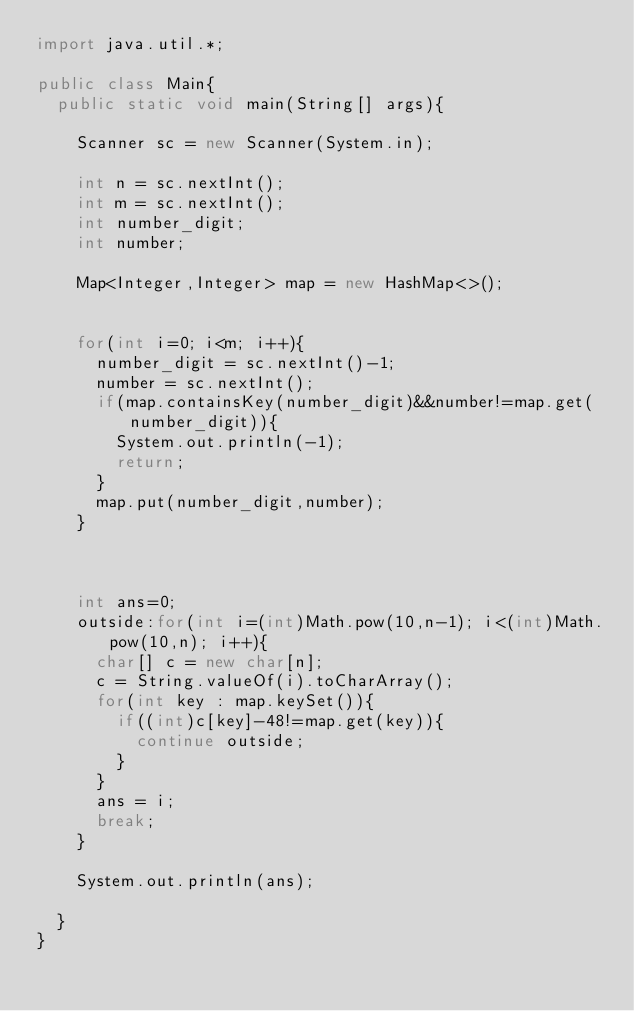<code> <loc_0><loc_0><loc_500><loc_500><_Java_>import java.util.*;

public class Main{
  public static void main(String[] args){

    Scanner sc = new Scanner(System.in);

    int n = sc.nextInt();
    int m = sc.nextInt();
    int number_digit;
    int number;

    Map<Integer,Integer> map = new HashMap<>();


    for(int i=0; i<m; i++){
      number_digit = sc.nextInt()-1;
      number = sc.nextInt();
      if(map.containsKey(number_digit)&&number!=map.get(number_digit)){
        System.out.println(-1);
        return;
      }
      map.put(number_digit,number);
    }



    int ans=0;
    outside:for(int i=(int)Math.pow(10,n-1); i<(int)Math.pow(10,n); i++){
      char[] c = new char[n];
      c = String.valueOf(i).toCharArray();
      for(int key : map.keySet()){
        if((int)c[key]-48!=map.get(key)){
          continue outside;
        }
      }
      ans = i;
      break;
    }

    System.out.println(ans);

  }
}</code> 